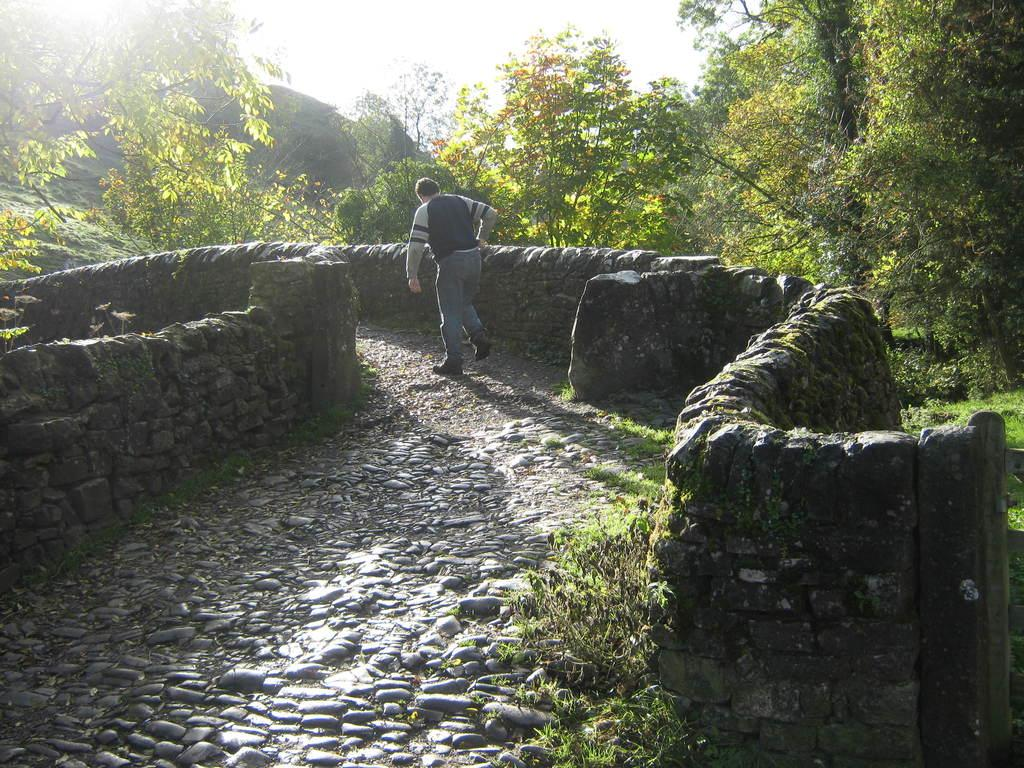Who is the main subject in the image? There is a man in the center of the image. What type of flooring is visible in the image? There is a pebbles floor in the center of the image. What can be seen in the background of the image? There are trees in the background of the image. How many spiders are crawling on the man's shirt in the image? There are no spiders visible on the man's shirt in the image. What type of grip does the man have on the fold of his shirt? The image does not show the man gripping his shirt or any folds in his clothing. 